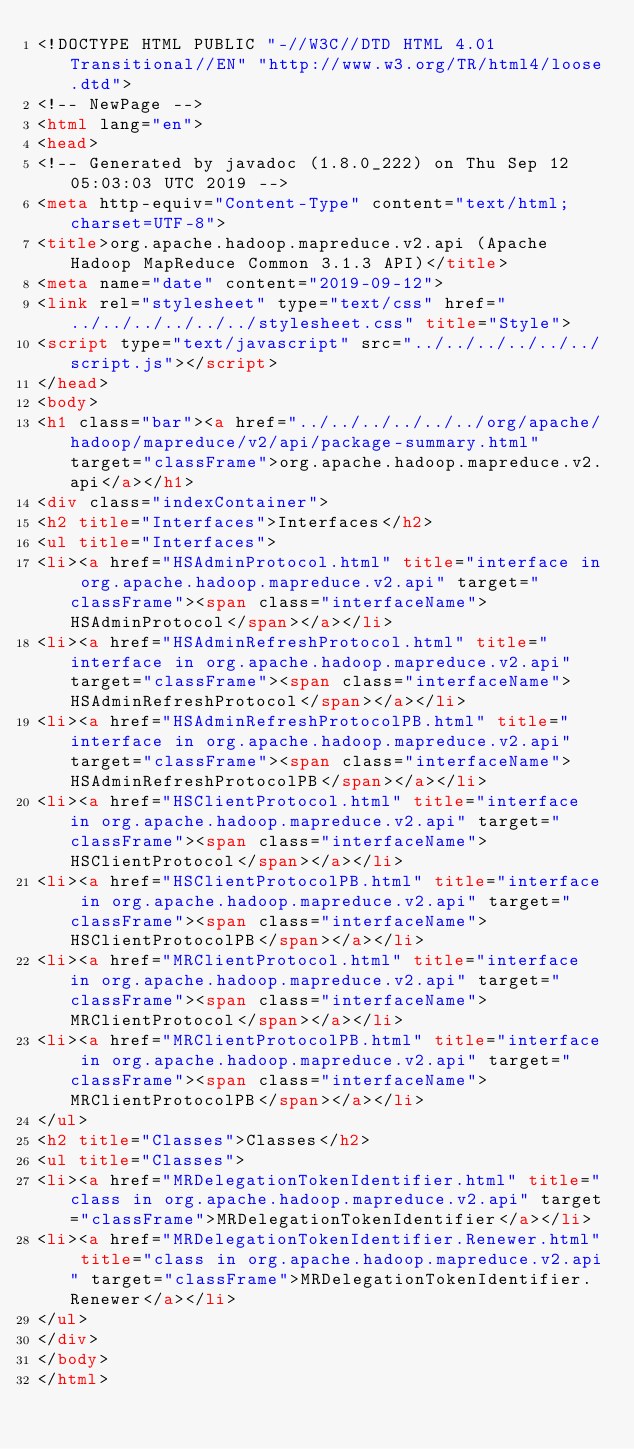Convert code to text. <code><loc_0><loc_0><loc_500><loc_500><_HTML_><!DOCTYPE HTML PUBLIC "-//W3C//DTD HTML 4.01 Transitional//EN" "http://www.w3.org/TR/html4/loose.dtd">
<!-- NewPage -->
<html lang="en">
<head>
<!-- Generated by javadoc (1.8.0_222) on Thu Sep 12 05:03:03 UTC 2019 -->
<meta http-equiv="Content-Type" content="text/html; charset=UTF-8">
<title>org.apache.hadoop.mapreduce.v2.api (Apache Hadoop MapReduce Common 3.1.3 API)</title>
<meta name="date" content="2019-09-12">
<link rel="stylesheet" type="text/css" href="../../../../../../stylesheet.css" title="Style">
<script type="text/javascript" src="../../../../../../script.js"></script>
</head>
<body>
<h1 class="bar"><a href="../../../../../../org/apache/hadoop/mapreduce/v2/api/package-summary.html" target="classFrame">org.apache.hadoop.mapreduce.v2.api</a></h1>
<div class="indexContainer">
<h2 title="Interfaces">Interfaces</h2>
<ul title="Interfaces">
<li><a href="HSAdminProtocol.html" title="interface in org.apache.hadoop.mapreduce.v2.api" target="classFrame"><span class="interfaceName">HSAdminProtocol</span></a></li>
<li><a href="HSAdminRefreshProtocol.html" title="interface in org.apache.hadoop.mapreduce.v2.api" target="classFrame"><span class="interfaceName">HSAdminRefreshProtocol</span></a></li>
<li><a href="HSAdminRefreshProtocolPB.html" title="interface in org.apache.hadoop.mapreduce.v2.api" target="classFrame"><span class="interfaceName">HSAdminRefreshProtocolPB</span></a></li>
<li><a href="HSClientProtocol.html" title="interface in org.apache.hadoop.mapreduce.v2.api" target="classFrame"><span class="interfaceName">HSClientProtocol</span></a></li>
<li><a href="HSClientProtocolPB.html" title="interface in org.apache.hadoop.mapreduce.v2.api" target="classFrame"><span class="interfaceName">HSClientProtocolPB</span></a></li>
<li><a href="MRClientProtocol.html" title="interface in org.apache.hadoop.mapreduce.v2.api" target="classFrame"><span class="interfaceName">MRClientProtocol</span></a></li>
<li><a href="MRClientProtocolPB.html" title="interface in org.apache.hadoop.mapreduce.v2.api" target="classFrame"><span class="interfaceName">MRClientProtocolPB</span></a></li>
</ul>
<h2 title="Classes">Classes</h2>
<ul title="Classes">
<li><a href="MRDelegationTokenIdentifier.html" title="class in org.apache.hadoop.mapreduce.v2.api" target="classFrame">MRDelegationTokenIdentifier</a></li>
<li><a href="MRDelegationTokenIdentifier.Renewer.html" title="class in org.apache.hadoop.mapreduce.v2.api" target="classFrame">MRDelegationTokenIdentifier.Renewer</a></li>
</ul>
</div>
</body>
</html>
</code> 